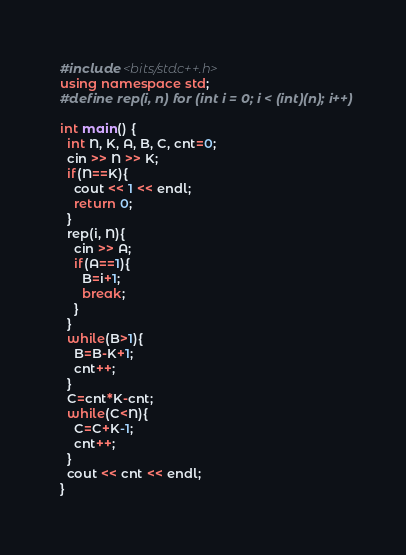Convert code to text. <code><loc_0><loc_0><loc_500><loc_500><_C++_>#include <bits/stdc++.h>
using namespace std;
#define rep(i, n) for (int i = 0; i < (int)(n); i++)

int main() {
  int N, K, A, B, C, cnt=0;
  cin >> N >> K;
  if(N==K){
    cout << 1 << endl;
    return 0;
  }
  rep(i, N){
    cin >> A;
    if(A==1){
      B=i+1;
      break;
    }
  }
  while(B>1){
    B=B-K+1;
    cnt++;
  }
  C=cnt*K-cnt;
  while(C<N){
    C=C+K-1;
    cnt++;
  }
  cout << cnt << endl;
}</code> 